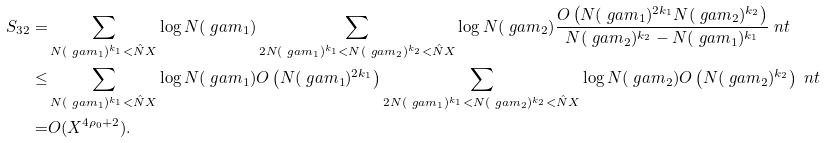<formula> <loc_0><loc_0><loc_500><loc_500>S _ { 3 2 } = & \sum _ { N ( \ g a m _ { 1 } ) ^ { k _ { 1 } } < \hat { N } X } \log { N ( \ g a m _ { 1 } ) } \sum _ { 2 N ( \ g a m _ { 1 } ) ^ { k _ { 1 } } < N ( \ g a m _ { 2 } ) ^ { k _ { 2 } } < \hat { N } X } \log { N ( \ g a m _ { 2 } ) } \frac { O \left ( N ( \ g a m _ { 1 } ) ^ { 2 k _ { 1 } } N ( \ g a m _ { 2 } ) ^ { k _ { 2 } } \right ) } { N ( \ g a m _ { 2 } ) ^ { k _ { 2 } } - N ( \ g a m _ { 1 } ) ^ { k _ { 1 } } } \ n t \\ \leq & \sum _ { N ( \ g a m _ { 1 } ) ^ { k _ { 1 } } < \hat { N } X } \log { N ( \ g a m _ { 1 } ) } O \left ( N ( \ g a m _ { 1 } ) ^ { 2 k _ { 1 } } \right ) \sum _ { 2 N ( \ g a m _ { 1 } ) ^ { k _ { 1 } } < N ( \ g a m _ { 2 } ) ^ { k _ { 2 } } < \hat { N } X } \log { N ( \ g a m _ { 2 } ) } O \left ( N ( \ g a m _ { 2 } ) ^ { k _ { 2 } } \right ) \ n t \\ = & O ( X ^ { 4 \rho _ { 0 } + 2 } ) .</formula> 